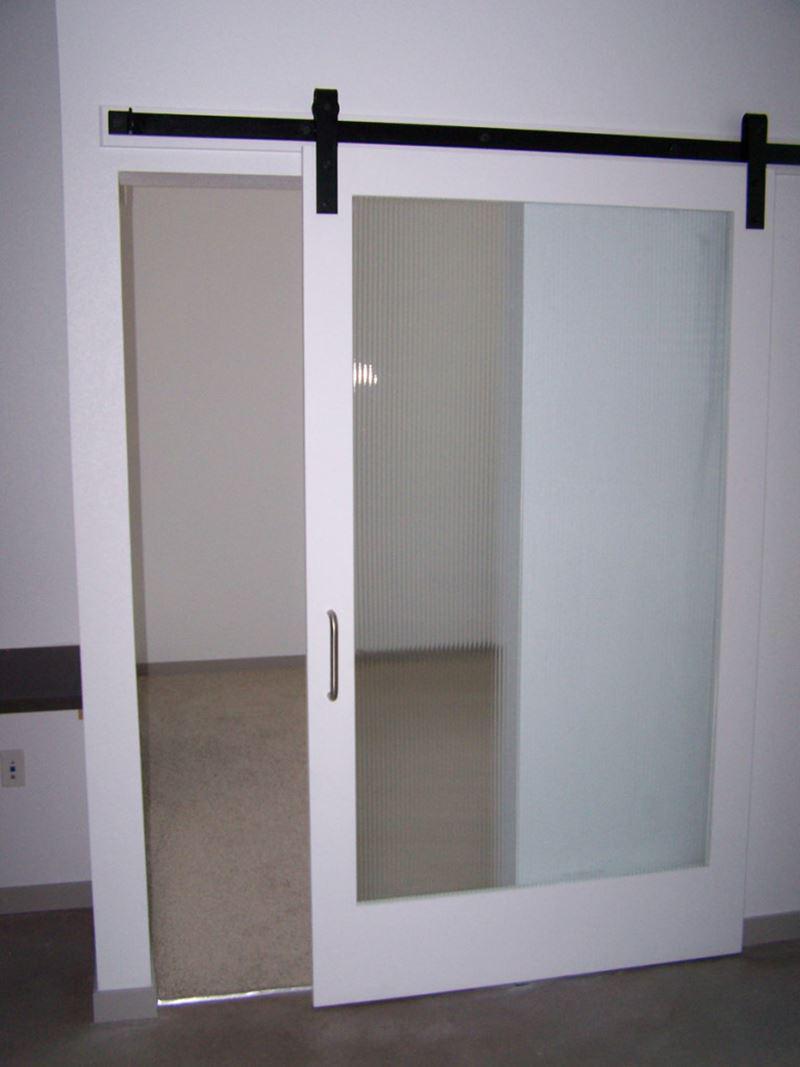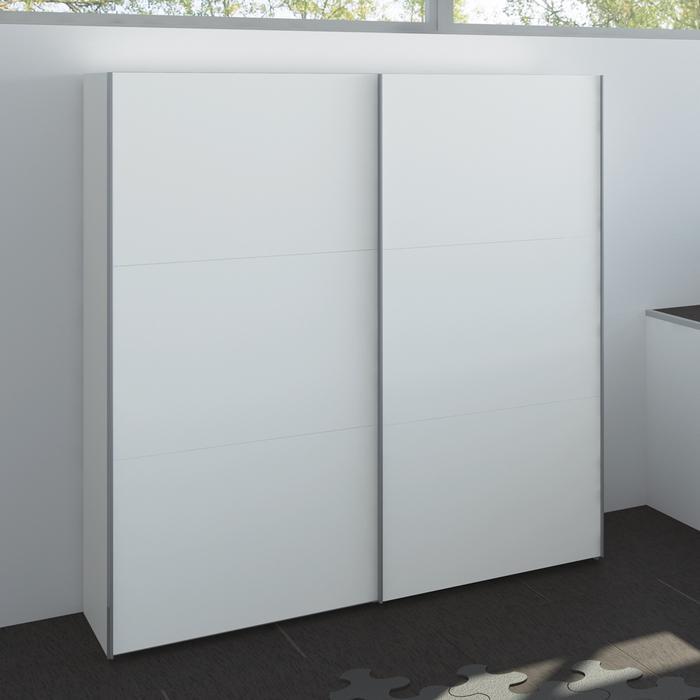The first image is the image on the left, the second image is the image on the right. Analyze the images presented: Is the assertion "An image shows a two door dimensional unit with a white front." valid? Answer yes or no. Yes. The first image is the image on the left, the second image is the image on the right. Analyze the images presented: Is the assertion "A free standing white cabinet with two closed doors is placed in front of a wall." valid? Answer yes or no. Yes. 